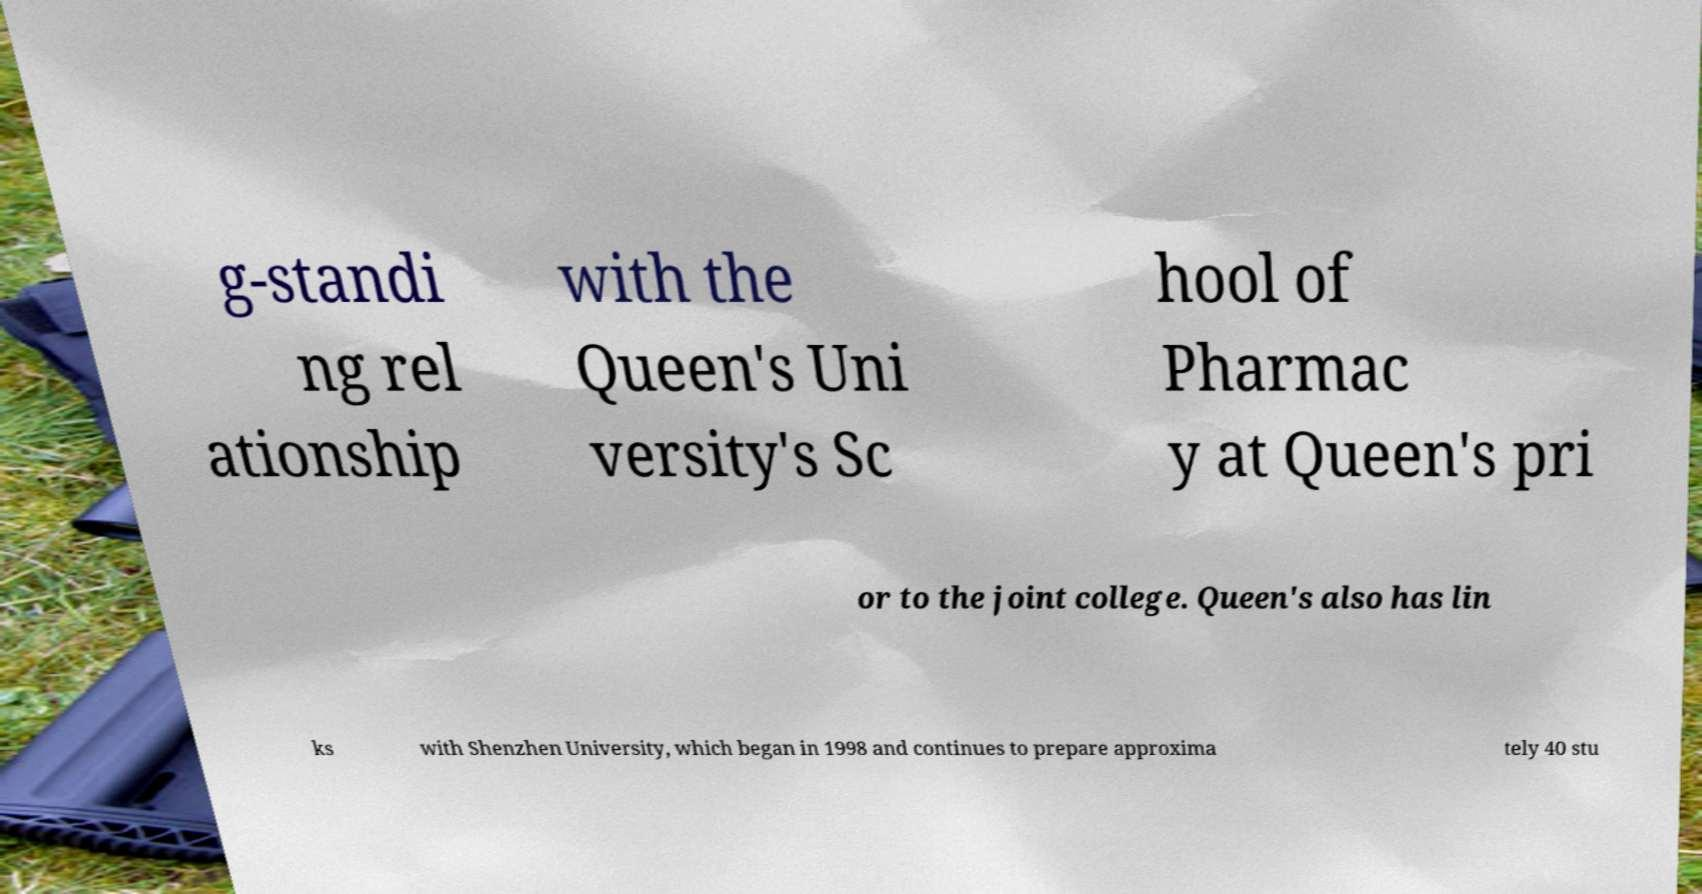Can you accurately transcribe the text from the provided image for me? g-standi ng rel ationship with the Queen's Uni versity's Sc hool of Pharmac y at Queen's pri or to the joint college. Queen's also has lin ks with Shenzhen University, which began in 1998 and continues to prepare approxima tely 40 stu 